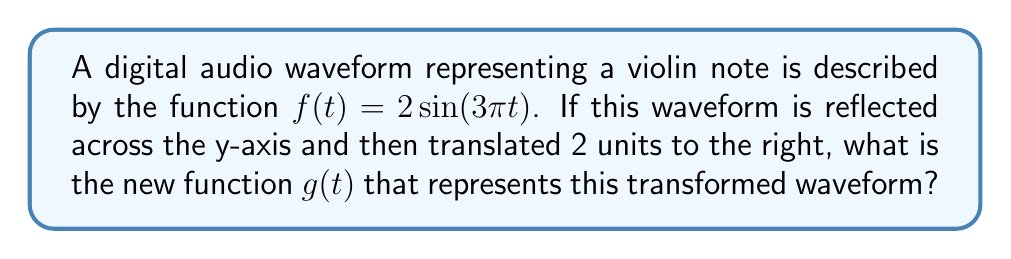Could you help me with this problem? Let's approach this step-by-step:

1) First, we need to reflect the function across the y-axis. This is done by replacing $t$ with $-t$ in the original function:

   $f(-t) = 2\sin(-3\pi t)$

2) Using the property that $\sin(-x) = -\sin(x)$, we can simplify this to:

   $f(-t) = -2\sin(3\pi t)$

3) Now, we need to translate this reflected function 2 units to the right. To translate a function h units to the right, we replace $t$ with $(t-h)$:

   $g(t) = -2\sin(3\pi(t-2))$

4) This is our final transformed function. However, we can expand this for clarity:

   $g(t) = -2\sin(3\pi t - 6\pi)$

5) Using the trigonometric identity $\sin(A-B) = \sin A \cos B - \cos A \sin B$, we get:

   $g(t) = -2(\sin(3\pi t)\cos(6\pi) - \cos(3\pi t)\sin(6\pi))$

6) Since $\cos(6\pi) = 1$ and $\sin(6\pi) = 0$, this simplifies to:

   $g(t) = -2\sin(3\pi t)$

This final form, $g(t) = -2\sin(3\pi t)$, represents our transformed waveform.
Answer: $g(t) = -2\sin(3\pi t)$ 